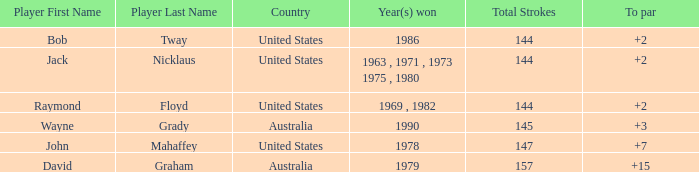What was the average round score of the player who won in 1978? 147.0. 